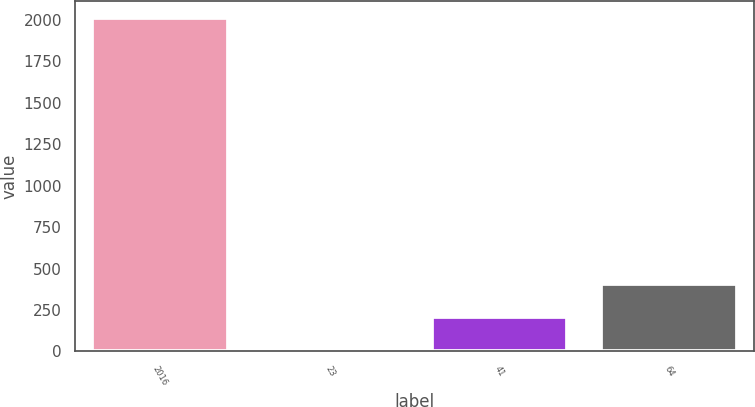Convert chart. <chart><loc_0><loc_0><loc_500><loc_500><bar_chart><fcel>2016<fcel>23<fcel>41<fcel>64<nl><fcel>2015<fcel>7<fcel>207.8<fcel>408.6<nl></chart> 